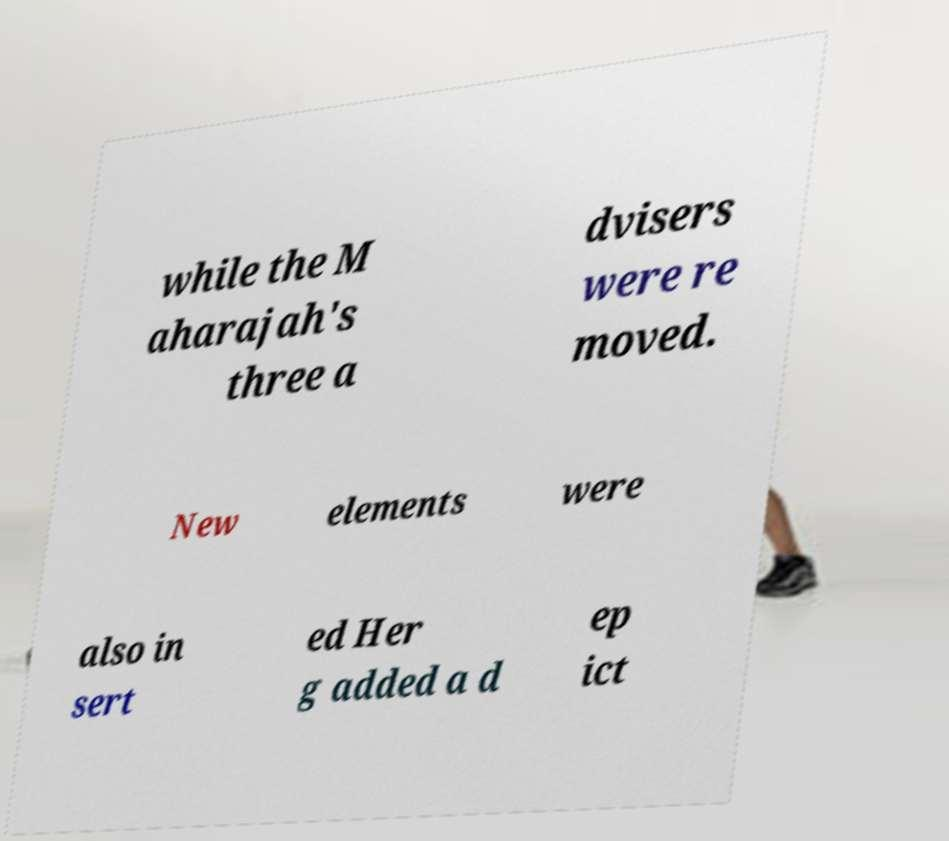There's text embedded in this image that I need extracted. Can you transcribe it verbatim? while the M aharajah's three a dvisers were re moved. New elements were also in sert ed Her g added a d ep ict 